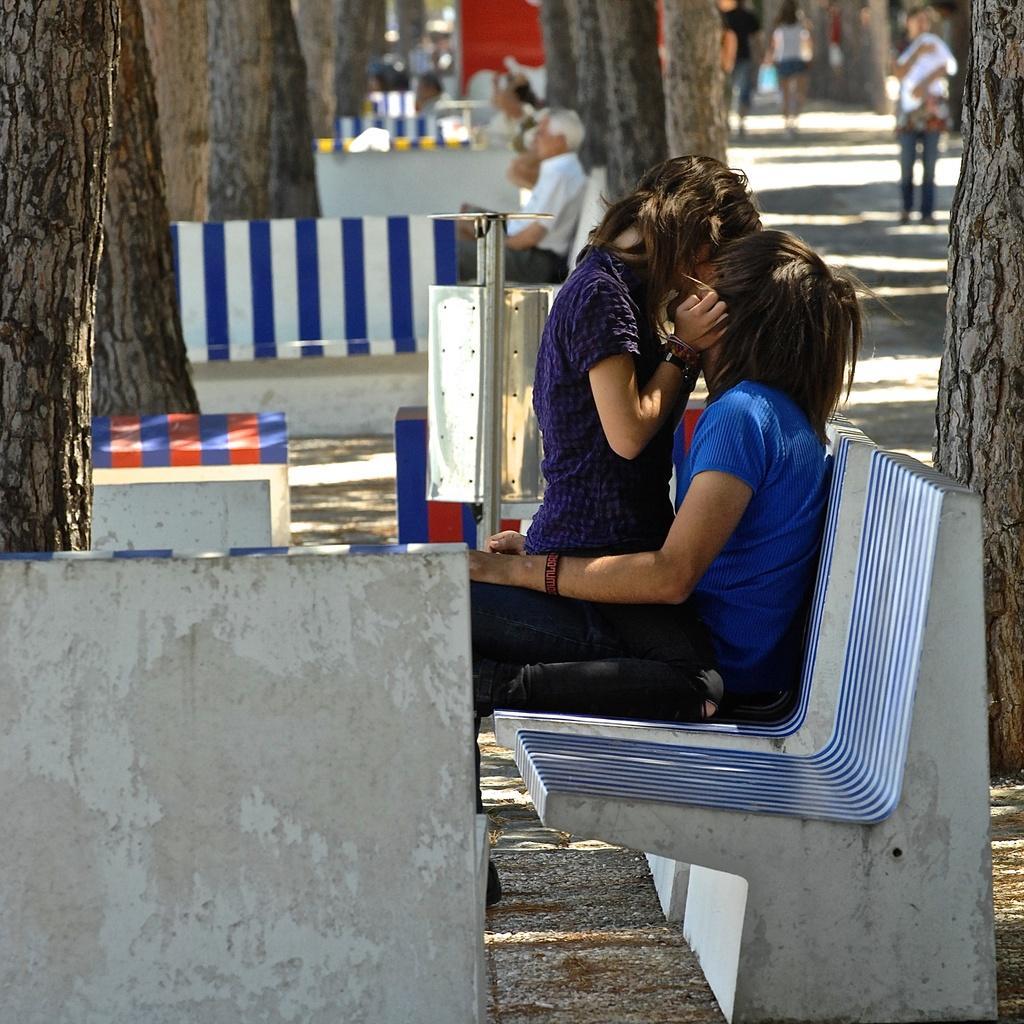Describe this image in one or two sentences. In this image we can see a boy and a girl are kissing each other by sitting on the bench. We can see few trees and people in the background. 